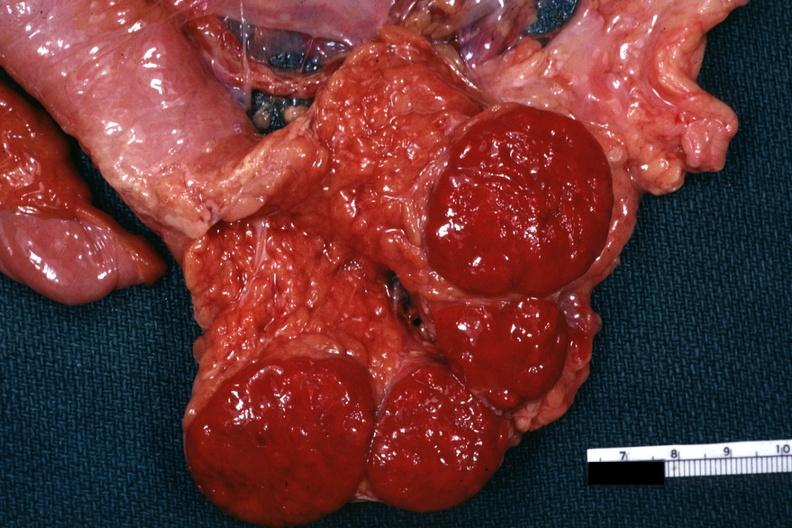s accessory spleens present?
Answer the question using a single word or phrase. Yes 